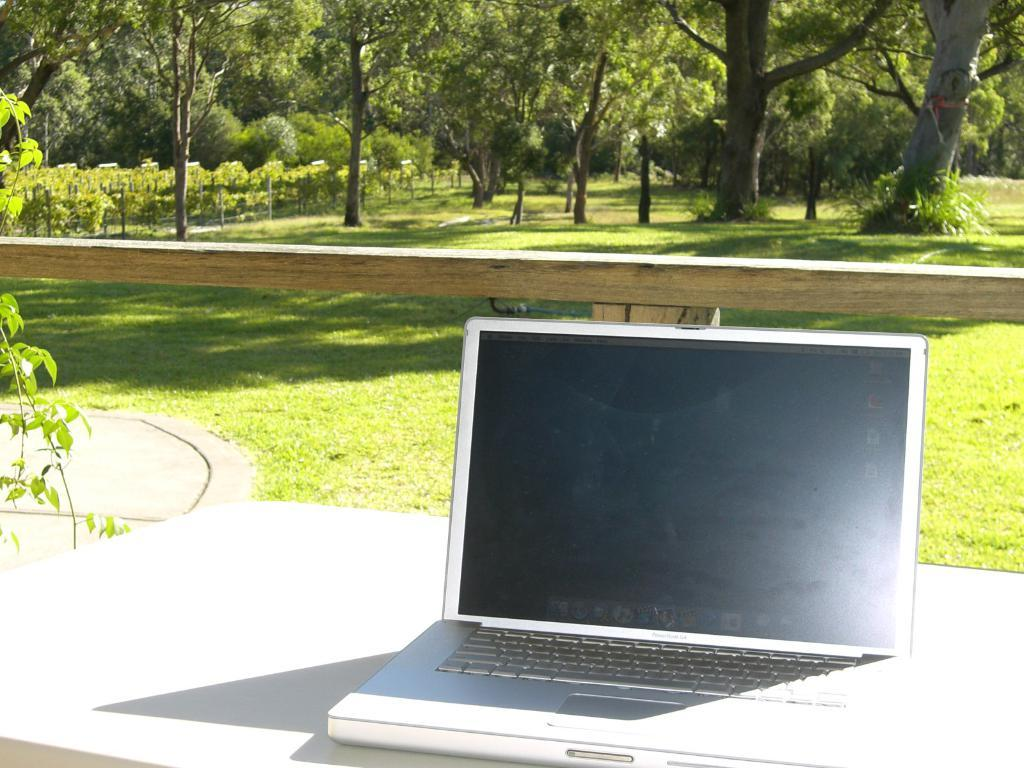What electronic device is on a platform in the image? There is a laptop on a platform in the image. What type of natural environment is visible in the image? There is grass, trees, and plants visible in the image. What material is used to create the wooden object in the image? The wooden object in the image is made of wood. What type of food is being prepared on the laptop in the image? There is no food preparation or cooking happening on the laptop in the image; it is an electronic device used for computing. 